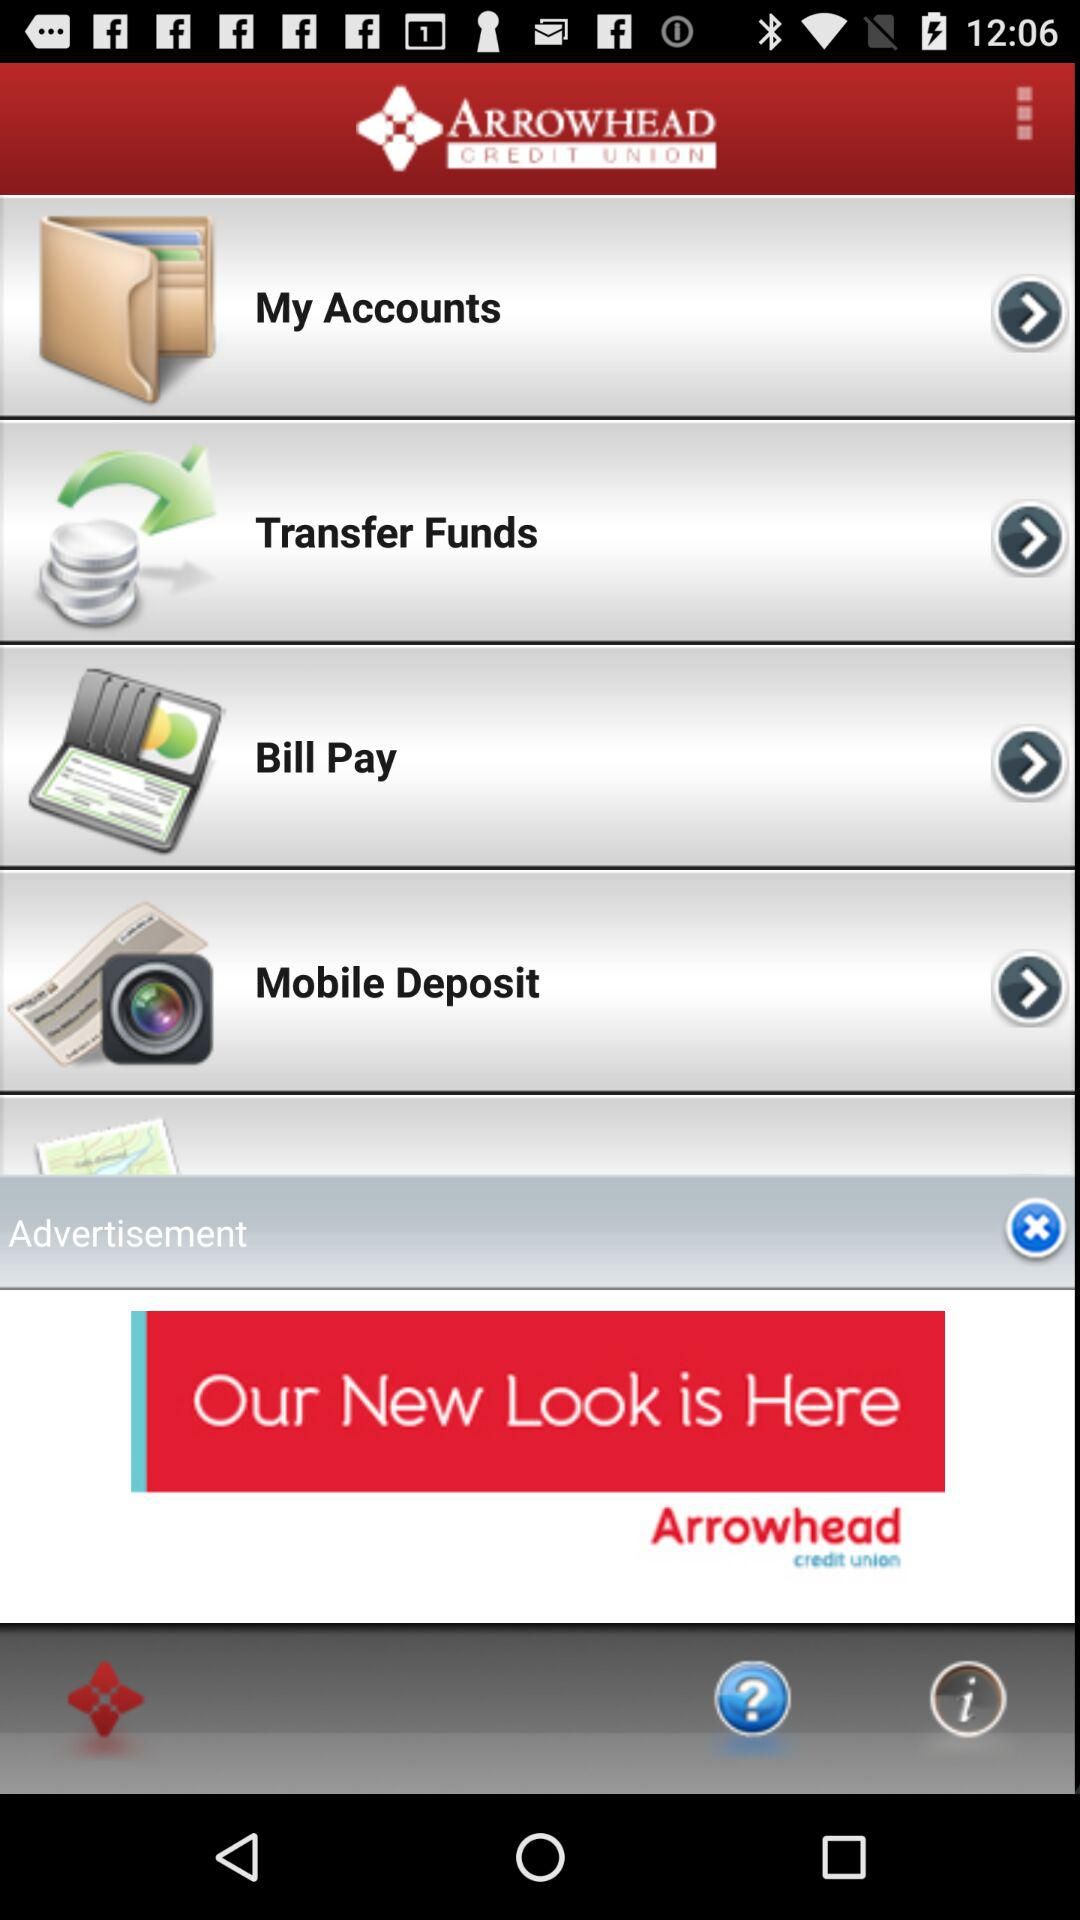What is the name of the application? The name of the application is "ARROWHEAD". 